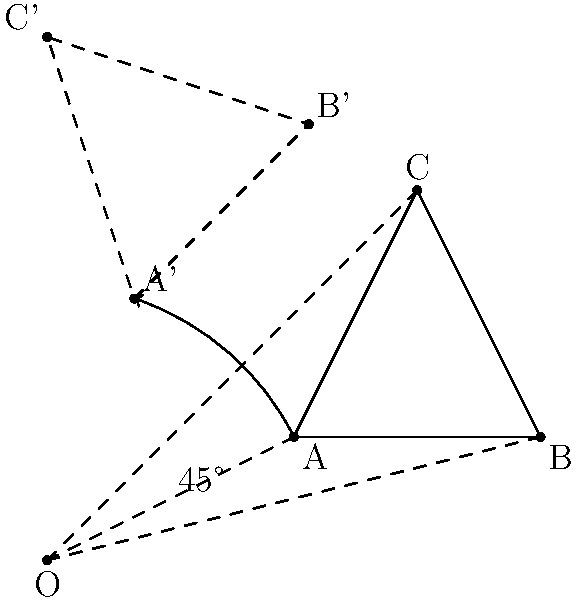In the diagram, triangle ABC is rotated 45° counterclockwise around point O. If the coordinates of point A are (2,1), what are the coordinates of point A' after rotation? Round your answer to two decimal places. To find the coordinates of point A' after a 45° counterclockwise rotation around the origin, we can use the rotation matrix:

$$R = \begin{bmatrix} \cos \theta & -\sin \theta \\ \sin \theta & \cos \theta \end{bmatrix}$$

Where $\theta = 45°$ or $\frac{\pi}{4}$ radians.

Steps:
1. Calculate $\cos 45°$ and $\sin 45°$:
   $\cos 45° = \sin 45° = \frac{\sqrt{2}}{2} \approx 0.7071$

2. Set up the rotation matrix:
   $$R = \begin{bmatrix} 0.7071 & -0.7071 \\ 0.7071 & 0.7071 \end{bmatrix}$$

3. Multiply the rotation matrix by the coordinates of point A:
   $$\begin{bmatrix} 0.7071 & -0.7071 \\ 0.7071 & 0.7071 \end{bmatrix} \begin{bmatrix} 2 \\ 1 \end{bmatrix}$$

4. Perform the matrix multiplication:
   $$\begin{bmatrix} (0.7071 \times 2) + (-0.7071 \times 1) \\ (0.7071 \times 2) + (0.7071 \times 1) \end{bmatrix}$$

5. Calculate the result:
   $$\begin{bmatrix} 0.7071 \\ 2.1213 \end{bmatrix}$$

6. Round to two decimal places:
   $$\begin{bmatrix} 0.71 \\ 2.12 \end{bmatrix}$$

Therefore, the coordinates of point A' after rotation are approximately (0.71, 2.12).
Answer: (0.71, 2.12) 